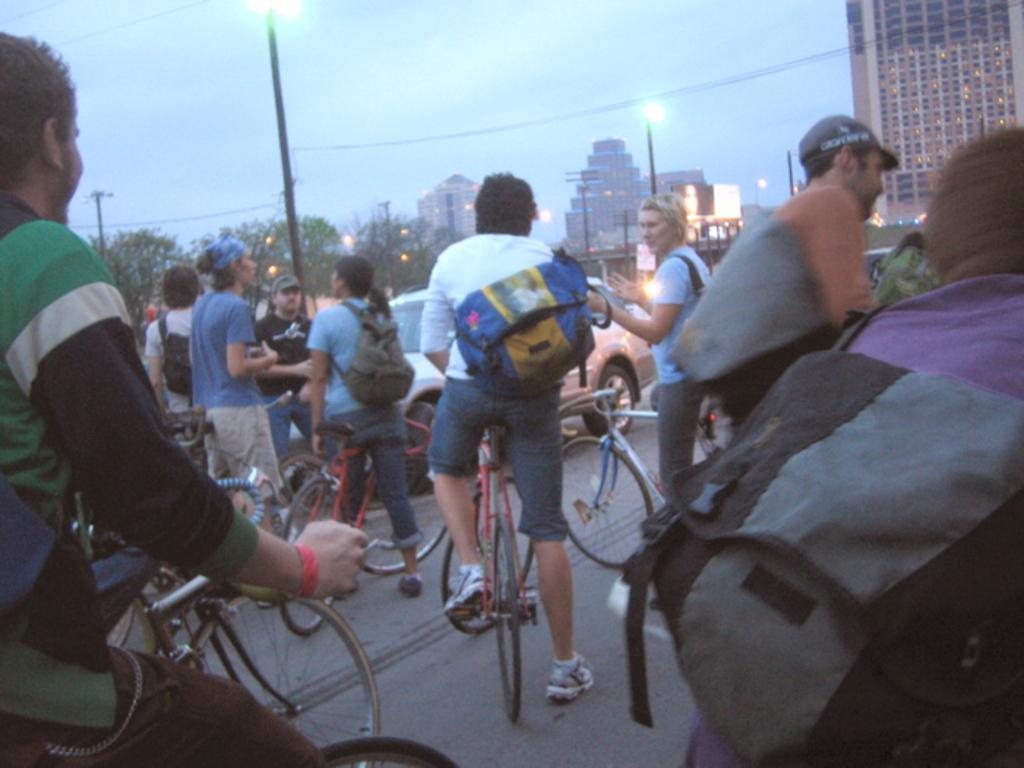Please provide a concise description of this image. In the image there are group of people riding a bicycle, on right side there are few people are standing and remaining few people are walking. On left we can also see a car, in background we can see a street light,building,trees and sky is on top. 